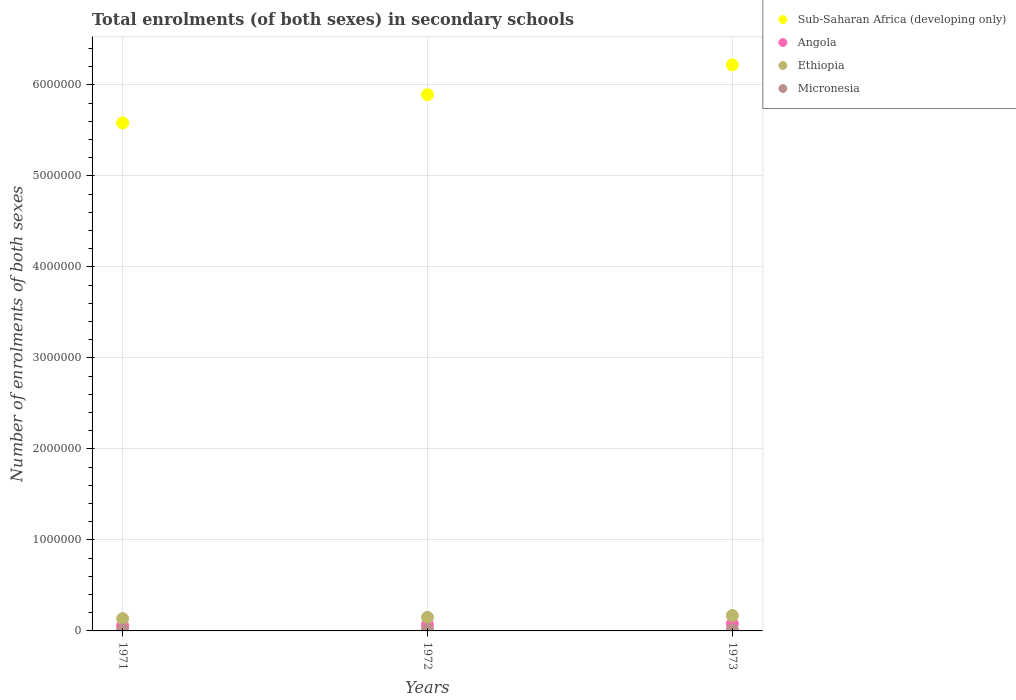What is the number of enrolments in secondary schools in Sub-Saharan Africa (developing only) in 1973?
Give a very brief answer. 6.22e+06. Across all years, what is the maximum number of enrolments in secondary schools in Sub-Saharan Africa (developing only)?
Provide a short and direct response. 6.22e+06. Across all years, what is the minimum number of enrolments in secondary schools in Ethiopia?
Make the answer very short. 1.35e+05. What is the total number of enrolments in secondary schools in Ethiopia in the graph?
Offer a terse response. 4.54e+05. What is the difference between the number of enrolments in secondary schools in Micronesia in 1972 and that in 1973?
Provide a short and direct response. -964. What is the difference between the number of enrolments in secondary schools in Angola in 1971 and the number of enrolments in secondary schools in Ethiopia in 1972?
Offer a terse response. -9.15e+04. What is the average number of enrolments in secondary schools in Sub-Saharan Africa (developing only) per year?
Offer a very short reply. 5.90e+06. In the year 1972, what is the difference between the number of enrolments in secondary schools in Micronesia and number of enrolments in secondary schools in Ethiopia?
Keep it short and to the point. -1.36e+05. In how many years, is the number of enrolments in secondary schools in Ethiopia greater than 4800000?
Provide a succinct answer. 0. What is the ratio of the number of enrolments in secondary schools in Angola in 1971 to that in 1972?
Provide a short and direct response. 0.86. What is the difference between the highest and the second highest number of enrolments in secondary schools in Sub-Saharan Africa (developing only)?
Give a very brief answer. 3.28e+05. What is the difference between the highest and the lowest number of enrolments in secondary schools in Sub-Saharan Africa (developing only)?
Provide a short and direct response. 6.39e+05. In how many years, is the number of enrolments in secondary schools in Micronesia greater than the average number of enrolments in secondary schools in Micronesia taken over all years?
Your answer should be compact. 1. Is it the case that in every year, the sum of the number of enrolments in secondary schools in Ethiopia and number of enrolments in secondary schools in Angola  is greater than the sum of number of enrolments in secondary schools in Micronesia and number of enrolments in secondary schools in Sub-Saharan Africa (developing only)?
Keep it short and to the point. No. Is the number of enrolments in secondary schools in Micronesia strictly greater than the number of enrolments in secondary schools in Sub-Saharan Africa (developing only) over the years?
Keep it short and to the point. No. Where does the legend appear in the graph?
Keep it short and to the point. Top right. How are the legend labels stacked?
Make the answer very short. Vertical. What is the title of the graph?
Provide a succinct answer. Total enrolments (of both sexes) in secondary schools. What is the label or title of the X-axis?
Ensure brevity in your answer.  Years. What is the label or title of the Y-axis?
Keep it short and to the point. Number of enrolments of both sexes. What is the Number of enrolments of both sexes of Sub-Saharan Africa (developing only) in 1971?
Your answer should be very brief. 5.58e+06. What is the Number of enrolments of both sexes of Angola in 1971?
Keep it short and to the point. 5.78e+04. What is the Number of enrolments of both sexes of Ethiopia in 1971?
Your answer should be very brief. 1.35e+05. What is the Number of enrolments of both sexes in Micronesia in 1971?
Give a very brief answer. 1.23e+04. What is the Number of enrolments of both sexes of Sub-Saharan Africa (developing only) in 1972?
Provide a succinct answer. 5.89e+06. What is the Number of enrolments of both sexes in Angola in 1972?
Your response must be concise. 6.72e+04. What is the Number of enrolments of both sexes in Ethiopia in 1972?
Your answer should be compact. 1.49e+05. What is the Number of enrolments of both sexes in Micronesia in 1972?
Ensure brevity in your answer.  1.31e+04. What is the Number of enrolments of both sexes in Sub-Saharan Africa (developing only) in 1973?
Give a very brief answer. 6.22e+06. What is the Number of enrolments of both sexes of Angola in 1973?
Your response must be concise. 7.91e+04. What is the Number of enrolments of both sexes of Ethiopia in 1973?
Provide a short and direct response. 1.70e+05. What is the Number of enrolments of both sexes in Micronesia in 1973?
Provide a short and direct response. 1.40e+04. Across all years, what is the maximum Number of enrolments of both sexes of Sub-Saharan Africa (developing only)?
Your answer should be compact. 6.22e+06. Across all years, what is the maximum Number of enrolments of both sexes of Angola?
Offer a terse response. 7.91e+04. Across all years, what is the maximum Number of enrolments of both sexes of Ethiopia?
Your response must be concise. 1.70e+05. Across all years, what is the maximum Number of enrolments of both sexes of Micronesia?
Your response must be concise. 1.40e+04. Across all years, what is the minimum Number of enrolments of both sexes of Sub-Saharan Africa (developing only)?
Offer a very short reply. 5.58e+06. Across all years, what is the minimum Number of enrolments of both sexes of Angola?
Offer a very short reply. 5.78e+04. Across all years, what is the minimum Number of enrolments of both sexes of Ethiopia?
Make the answer very short. 1.35e+05. Across all years, what is the minimum Number of enrolments of both sexes of Micronesia?
Give a very brief answer. 1.23e+04. What is the total Number of enrolments of both sexes in Sub-Saharan Africa (developing only) in the graph?
Make the answer very short. 1.77e+07. What is the total Number of enrolments of both sexes in Angola in the graph?
Provide a short and direct response. 2.04e+05. What is the total Number of enrolments of both sexes in Ethiopia in the graph?
Your answer should be compact. 4.54e+05. What is the total Number of enrolments of both sexes of Micronesia in the graph?
Your answer should be very brief. 3.94e+04. What is the difference between the Number of enrolments of both sexes of Sub-Saharan Africa (developing only) in 1971 and that in 1972?
Provide a succinct answer. -3.11e+05. What is the difference between the Number of enrolments of both sexes of Angola in 1971 and that in 1972?
Keep it short and to the point. -9401. What is the difference between the Number of enrolments of both sexes of Ethiopia in 1971 and that in 1972?
Your answer should be compact. -1.41e+04. What is the difference between the Number of enrolments of both sexes of Micronesia in 1971 and that in 1972?
Provide a short and direct response. -771. What is the difference between the Number of enrolments of both sexes of Sub-Saharan Africa (developing only) in 1971 and that in 1973?
Offer a terse response. -6.39e+05. What is the difference between the Number of enrolments of both sexes in Angola in 1971 and that in 1973?
Make the answer very short. -2.12e+04. What is the difference between the Number of enrolments of both sexes in Ethiopia in 1971 and that in 1973?
Provide a short and direct response. -3.45e+04. What is the difference between the Number of enrolments of both sexes of Micronesia in 1971 and that in 1973?
Make the answer very short. -1735. What is the difference between the Number of enrolments of both sexes in Sub-Saharan Africa (developing only) in 1972 and that in 1973?
Ensure brevity in your answer.  -3.28e+05. What is the difference between the Number of enrolments of both sexes in Angola in 1972 and that in 1973?
Your answer should be very brief. -1.18e+04. What is the difference between the Number of enrolments of both sexes in Ethiopia in 1972 and that in 1973?
Offer a terse response. -2.03e+04. What is the difference between the Number of enrolments of both sexes in Micronesia in 1972 and that in 1973?
Offer a terse response. -964. What is the difference between the Number of enrolments of both sexes in Sub-Saharan Africa (developing only) in 1971 and the Number of enrolments of both sexes in Angola in 1972?
Give a very brief answer. 5.51e+06. What is the difference between the Number of enrolments of both sexes in Sub-Saharan Africa (developing only) in 1971 and the Number of enrolments of both sexes in Ethiopia in 1972?
Your answer should be compact. 5.43e+06. What is the difference between the Number of enrolments of both sexes in Sub-Saharan Africa (developing only) in 1971 and the Number of enrolments of both sexes in Micronesia in 1972?
Your answer should be very brief. 5.57e+06. What is the difference between the Number of enrolments of both sexes of Angola in 1971 and the Number of enrolments of both sexes of Ethiopia in 1972?
Provide a succinct answer. -9.15e+04. What is the difference between the Number of enrolments of both sexes in Angola in 1971 and the Number of enrolments of both sexes in Micronesia in 1972?
Your answer should be very brief. 4.48e+04. What is the difference between the Number of enrolments of both sexes in Ethiopia in 1971 and the Number of enrolments of both sexes in Micronesia in 1972?
Offer a terse response. 1.22e+05. What is the difference between the Number of enrolments of both sexes of Sub-Saharan Africa (developing only) in 1971 and the Number of enrolments of both sexes of Angola in 1973?
Give a very brief answer. 5.50e+06. What is the difference between the Number of enrolments of both sexes of Sub-Saharan Africa (developing only) in 1971 and the Number of enrolments of both sexes of Ethiopia in 1973?
Offer a terse response. 5.41e+06. What is the difference between the Number of enrolments of both sexes of Sub-Saharan Africa (developing only) in 1971 and the Number of enrolments of both sexes of Micronesia in 1973?
Offer a terse response. 5.57e+06. What is the difference between the Number of enrolments of both sexes of Angola in 1971 and the Number of enrolments of both sexes of Ethiopia in 1973?
Offer a terse response. -1.12e+05. What is the difference between the Number of enrolments of both sexes of Angola in 1971 and the Number of enrolments of both sexes of Micronesia in 1973?
Offer a terse response. 4.38e+04. What is the difference between the Number of enrolments of both sexes in Ethiopia in 1971 and the Number of enrolments of both sexes in Micronesia in 1973?
Offer a terse response. 1.21e+05. What is the difference between the Number of enrolments of both sexes of Sub-Saharan Africa (developing only) in 1972 and the Number of enrolments of both sexes of Angola in 1973?
Ensure brevity in your answer.  5.81e+06. What is the difference between the Number of enrolments of both sexes of Sub-Saharan Africa (developing only) in 1972 and the Number of enrolments of both sexes of Ethiopia in 1973?
Provide a succinct answer. 5.72e+06. What is the difference between the Number of enrolments of both sexes of Sub-Saharan Africa (developing only) in 1972 and the Number of enrolments of both sexes of Micronesia in 1973?
Give a very brief answer. 5.88e+06. What is the difference between the Number of enrolments of both sexes of Angola in 1972 and the Number of enrolments of both sexes of Ethiopia in 1973?
Your response must be concise. -1.02e+05. What is the difference between the Number of enrolments of both sexes in Angola in 1972 and the Number of enrolments of both sexes in Micronesia in 1973?
Provide a succinct answer. 5.32e+04. What is the difference between the Number of enrolments of both sexes of Ethiopia in 1972 and the Number of enrolments of both sexes of Micronesia in 1973?
Give a very brief answer. 1.35e+05. What is the average Number of enrolments of both sexes in Sub-Saharan Africa (developing only) per year?
Give a very brief answer. 5.90e+06. What is the average Number of enrolments of both sexes in Angola per year?
Ensure brevity in your answer.  6.80e+04. What is the average Number of enrolments of both sexes in Ethiopia per year?
Keep it short and to the point. 1.51e+05. What is the average Number of enrolments of both sexes in Micronesia per year?
Your response must be concise. 1.31e+04. In the year 1971, what is the difference between the Number of enrolments of both sexes in Sub-Saharan Africa (developing only) and Number of enrolments of both sexes in Angola?
Make the answer very short. 5.52e+06. In the year 1971, what is the difference between the Number of enrolments of both sexes of Sub-Saharan Africa (developing only) and Number of enrolments of both sexes of Ethiopia?
Provide a succinct answer. 5.45e+06. In the year 1971, what is the difference between the Number of enrolments of both sexes in Sub-Saharan Africa (developing only) and Number of enrolments of both sexes in Micronesia?
Your response must be concise. 5.57e+06. In the year 1971, what is the difference between the Number of enrolments of both sexes of Angola and Number of enrolments of both sexes of Ethiopia?
Your answer should be compact. -7.74e+04. In the year 1971, what is the difference between the Number of enrolments of both sexes in Angola and Number of enrolments of both sexes in Micronesia?
Give a very brief answer. 4.55e+04. In the year 1971, what is the difference between the Number of enrolments of both sexes in Ethiopia and Number of enrolments of both sexes in Micronesia?
Your response must be concise. 1.23e+05. In the year 1972, what is the difference between the Number of enrolments of both sexes in Sub-Saharan Africa (developing only) and Number of enrolments of both sexes in Angola?
Keep it short and to the point. 5.83e+06. In the year 1972, what is the difference between the Number of enrolments of both sexes in Sub-Saharan Africa (developing only) and Number of enrolments of both sexes in Ethiopia?
Offer a terse response. 5.74e+06. In the year 1972, what is the difference between the Number of enrolments of both sexes of Sub-Saharan Africa (developing only) and Number of enrolments of both sexes of Micronesia?
Ensure brevity in your answer.  5.88e+06. In the year 1972, what is the difference between the Number of enrolments of both sexes of Angola and Number of enrolments of both sexes of Ethiopia?
Provide a succinct answer. -8.21e+04. In the year 1972, what is the difference between the Number of enrolments of both sexes of Angola and Number of enrolments of both sexes of Micronesia?
Make the answer very short. 5.42e+04. In the year 1972, what is the difference between the Number of enrolments of both sexes in Ethiopia and Number of enrolments of both sexes in Micronesia?
Make the answer very short. 1.36e+05. In the year 1973, what is the difference between the Number of enrolments of both sexes in Sub-Saharan Africa (developing only) and Number of enrolments of both sexes in Angola?
Offer a very short reply. 6.14e+06. In the year 1973, what is the difference between the Number of enrolments of both sexes in Sub-Saharan Africa (developing only) and Number of enrolments of both sexes in Ethiopia?
Your answer should be very brief. 6.05e+06. In the year 1973, what is the difference between the Number of enrolments of both sexes of Sub-Saharan Africa (developing only) and Number of enrolments of both sexes of Micronesia?
Keep it short and to the point. 6.21e+06. In the year 1973, what is the difference between the Number of enrolments of both sexes of Angola and Number of enrolments of both sexes of Ethiopia?
Make the answer very short. -9.06e+04. In the year 1973, what is the difference between the Number of enrolments of both sexes of Angola and Number of enrolments of both sexes of Micronesia?
Your answer should be very brief. 6.50e+04. In the year 1973, what is the difference between the Number of enrolments of both sexes in Ethiopia and Number of enrolments of both sexes in Micronesia?
Give a very brief answer. 1.56e+05. What is the ratio of the Number of enrolments of both sexes in Sub-Saharan Africa (developing only) in 1971 to that in 1972?
Give a very brief answer. 0.95. What is the ratio of the Number of enrolments of both sexes in Angola in 1971 to that in 1972?
Keep it short and to the point. 0.86. What is the ratio of the Number of enrolments of both sexes of Ethiopia in 1971 to that in 1972?
Ensure brevity in your answer.  0.91. What is the ratio of the Number of enrolments of both sexes in Micronesia in 1971 to that in 1972?
Provide a short and direct response. 0.94. What is the ratio of the Number of enrolments of both sexes of Sub-Saharan Africa (developing only) in 1971 to that in 1973?
Ensure brevity in your answer.  0.9. What is the ratio of the Number of enrolments of both sexes in Angola in 1971 to that in 1973?
Ensure brevity in your answer.  0.73. What is the ratio of the Number of enrolments of both sexes of Ethiopia in 1971 to that in 1973?
Ensure brevity in your answer.  0.8. What is the ratio of the Number of enrolments of both sexes in Micronesia in 1971 to that in 1973?
Your response must be concise. 0.88. What is the ratio of the Number of enrolments of both sexes in Sub-Saharan Africa (developing only) in 1972 to that in 1973?
Ensure brevity in your answer.  0.95. What is the ratio of the Number of enrolments of both sexes of Angola in 1972 to that in 1973?
Your answer should be very brief. 0.85. What is the ratio of the Number of enrolments of both sexes of Ethiopia in 1972 to that in 1973?
Give a very brief answer. 0.88. What is the ratio of the Number of enrolments of both sexes of Micronesia in 1972 to that in 1973?
Your response must be concise. 0.93. What is the difference between the highest and the second highest Number of enrolments of both sexes of Sub-Saharan Africa (developing only)?
Ensure brevity in your answer.  3.28e+05. What is the difference between the highest and the second highest Number of enrolments of both sexes in Angola?
Provide a short and direct response. 1.18e+04. What is the difference between the highest and the second highest Number of enrolments of both sexes in Ethiopia?
Offer a terse response. 2.03e+04. What is the difference between the highest and the second highest Number of enrolments of both sexes of Micronesia?
Your answer should be compact. 964. What is the difference between the highest and the lowest Number of enrolments of both sexes in Sub-Saharan Africa (developing only)?
Your answer should be compact. 6.39e+05. What is the difference between the highest and the lowest Number of enrolments of both sexes of Angola?
Keep it short and to the point. 2.12e+04. What is the difference between the highest and the lowest Number of enrolments of both sexes of Ethiopia?
Provide a short and direct response. 3.45e+04. What is the difference between the highest and the lowest Number of enrolments of both sexes in Micronesia?
Provide a succinct answer. 1735. 